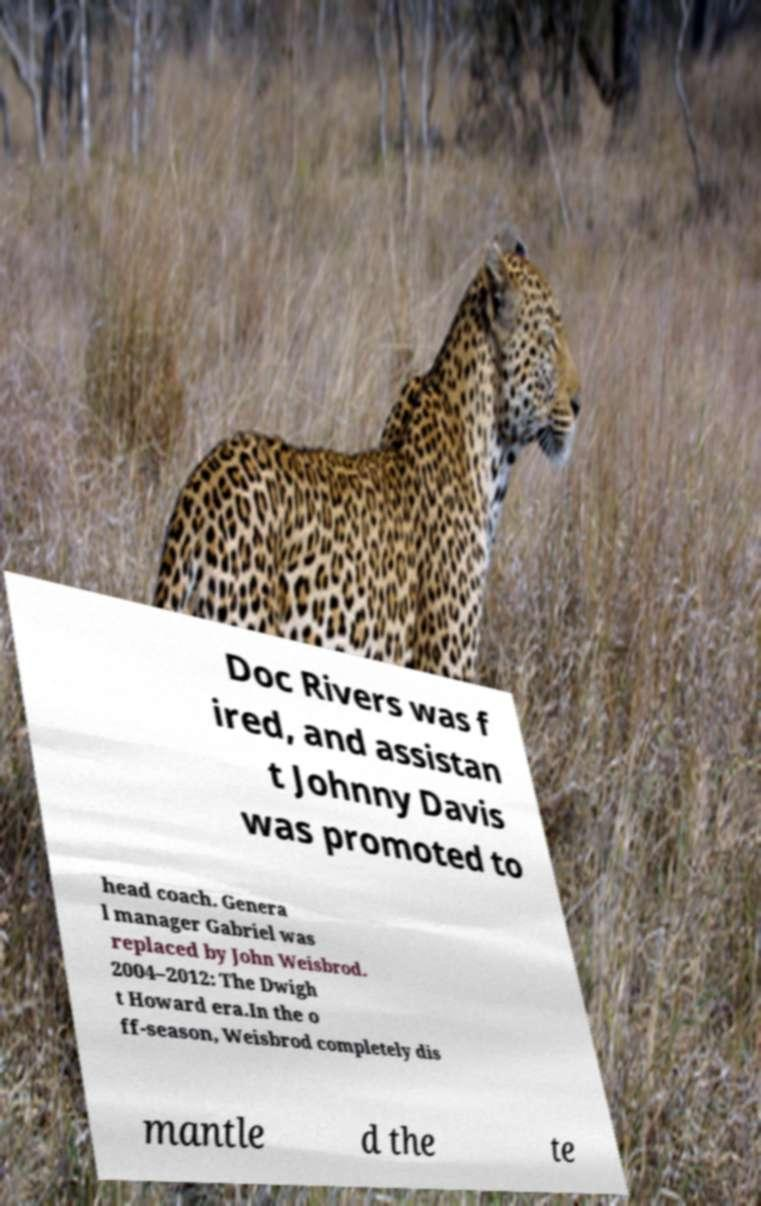What messages or text are displayed in this image? I need them in a readable, typed format. Doc Rivers was f ired, and assistan t Johnny Davis was promoted to head coach. Genera l manager Gabriel was replaced by John Weisbrod. 2004–2012: The Dwigh t Howard era.In the o ff-season, Weisbrod completely dis mantle d the te 